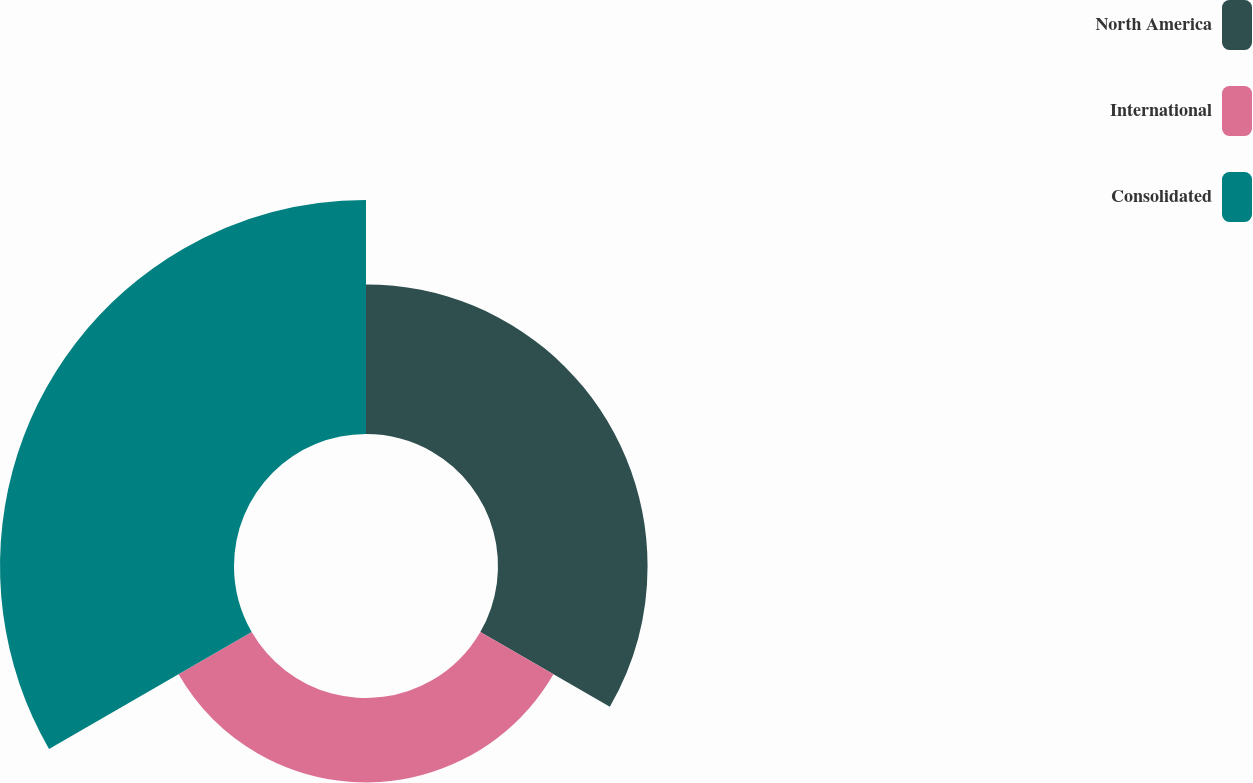<chart> <loc_0><loc_0><loc_500><loc_500><pie_chart><fcel>North America<fcel>International<fcel>Consolidated<nl><fcel>31.96%<fcel>18.04%<fcel>50.0%<nl></chart> 